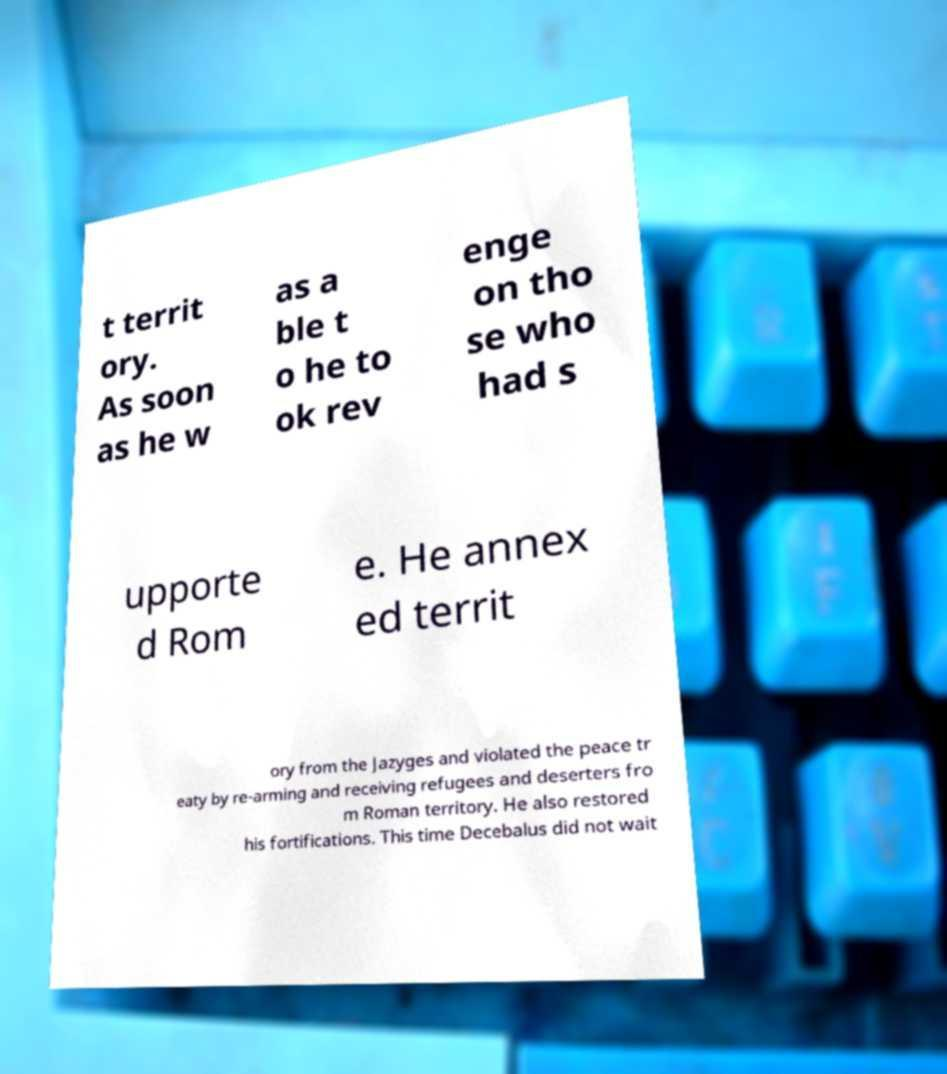What messages or text are displayed in this image? I need them in a readable, typed format. t territ ory. As soon as he w as a ble t o he to ok rev enge on tho se who had s upporte d Rom e. He annex ed territ ory from the Jazyges and violated the peace tr eaty by re-arming and receiving refugees and deserters fro m Roman territory. He also restored his fortifications. This time Decebalus did not wait 